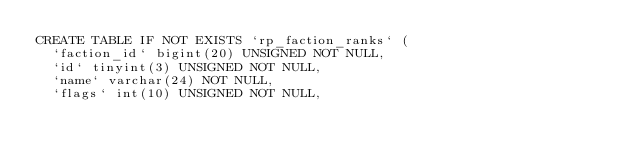Convert code to text. <code><loc_0><loc_0><loc_500><loc_500><_SQL_>CREATE TABLE IF NOT EXISTS `rp_faction_ranks` (
  `faction_id` bigint(20) UNSIGNED NOT NULL,
  `id` tinyint(3) UNSIGNED NOT NULL,
  `name` varchar(24) NOT NULL,
  `flags` int(10) UNSIGNED NOT NULL,</code> 